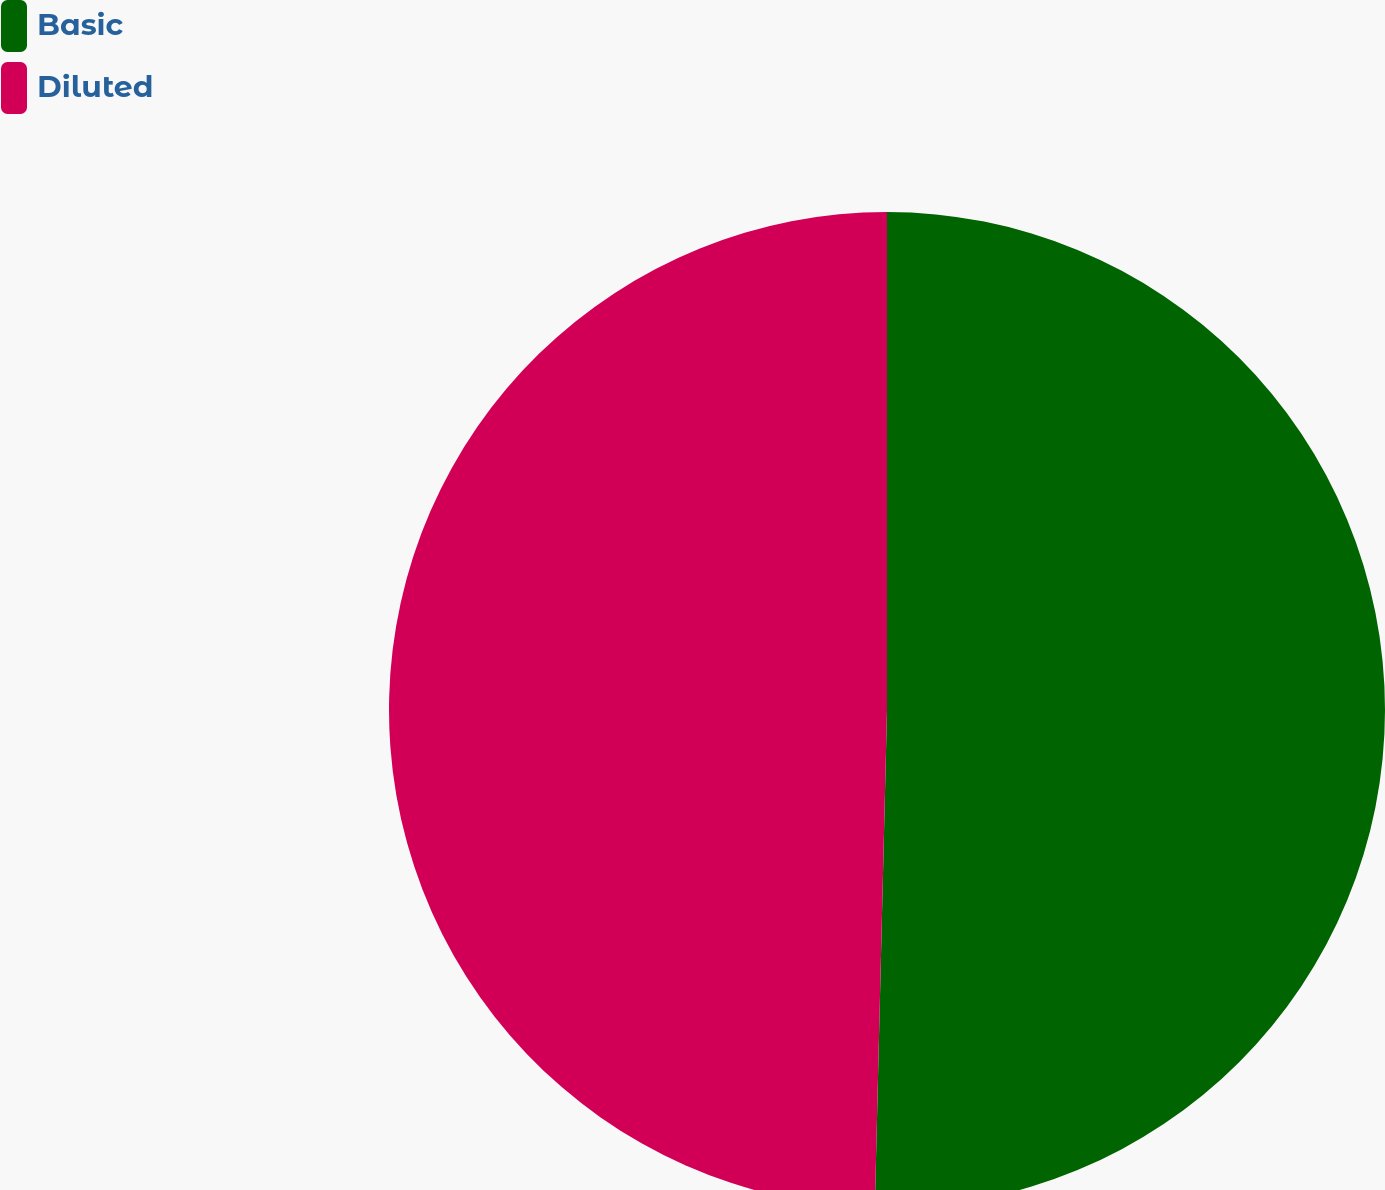Convert chart. <chart><loc_0><loc_0><loc_500><loc_500><pie_chart><fcel>Basic<fcel>Diluted<nl><fcel>50.39%<fcel>49.61%<nl></chart> 